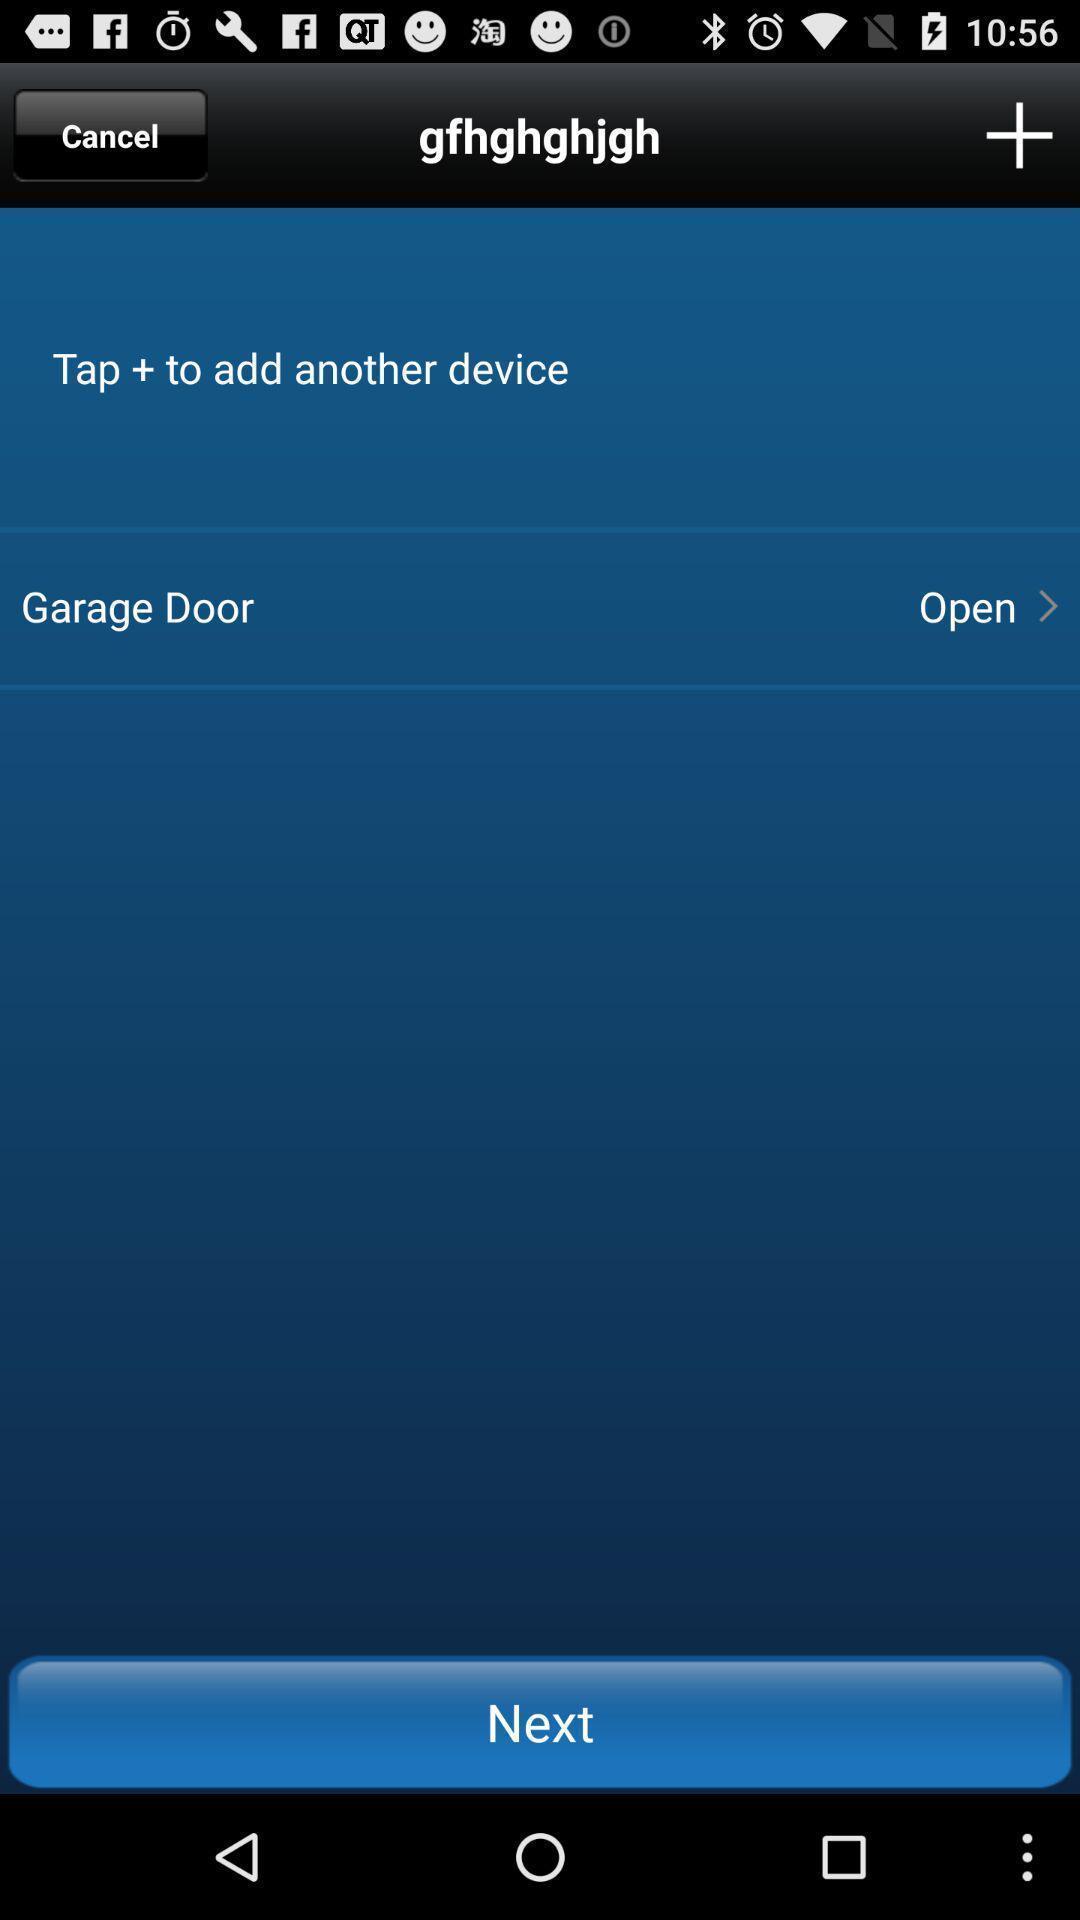Explain the elements present in this screenshot. Page showing option to add a device with other options. 